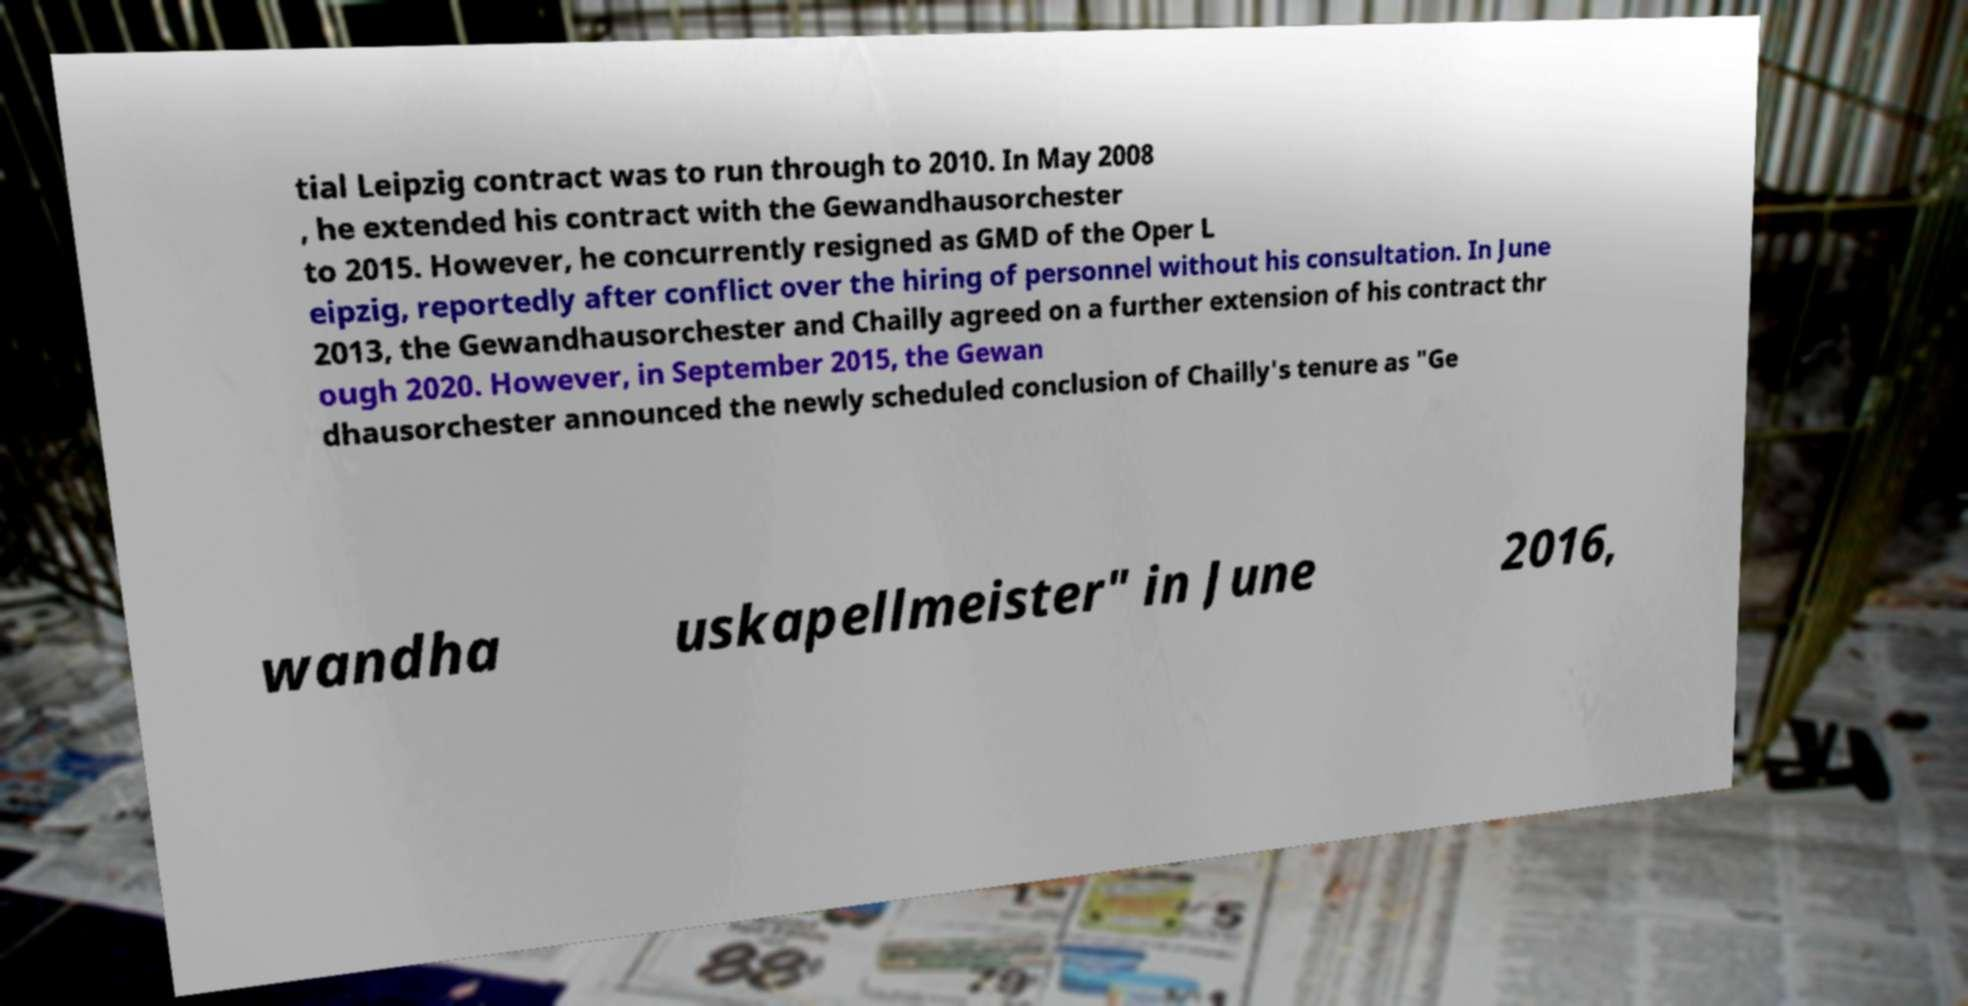Can you read and provide the text displayed in the image?This photo seems to have some interesting text. Can you extract and type it out for me? tial Leipzig contract was to run through to 2010. In May 2008 , he extended his contract with the Gewandhausorchester to 2015. However, he concurrently resigned as GMD of the Oper L eipzig, reportedly after conflict over the hiring of personnel without his consultation. In June 2013, the Gewandhausorchester and Chailly agreed on a further extension of his contract thr ough 2020. However, in September 2015, the Gewan dhausorchester announced the newly scheduled conclusion of Chailly's tenure as "Ge wandha uskapellmeister" in June 2016, 